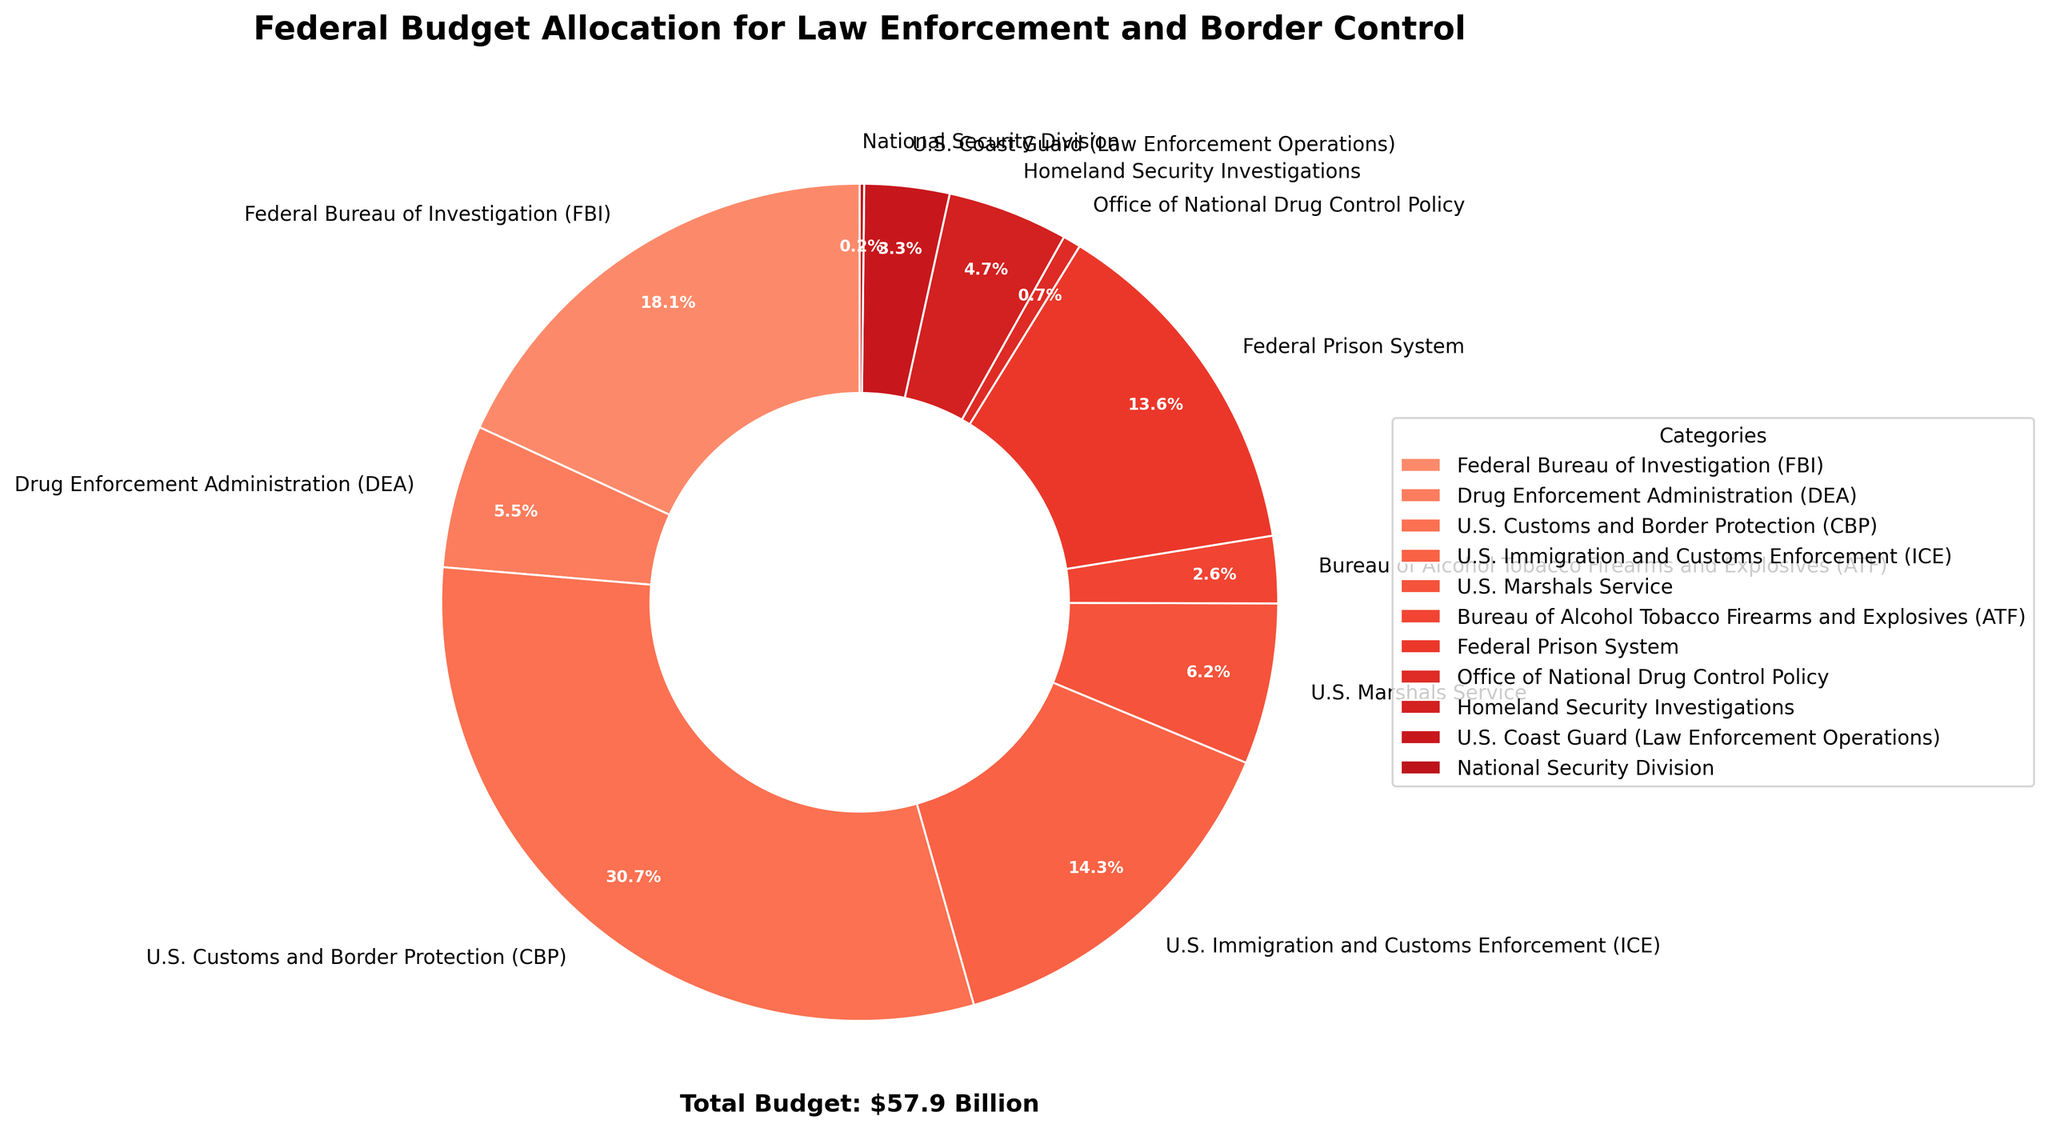What categories receive less than 5% of the total budget each? First, identify the categories with budget allocations below 5% from the pie chart. The total budget is 57.9 billion from the chart. For less than 5%, a category should receive less than 0.05 * 57.9 = 2.895 billion. The relevant categories are DEA, ATF, Office of National Drug Control Policy, Homeland Security Investigations, National Security Division, and U.S. Coast Guard (Law Enforcement Operations).
Answer: DEA, ATF, Office of National Drug Control Policy, Homeland Security Investigations, National Security Division, U.S. Coast Guard (Law Enforcement Operations) Which law enforcement category receives the highest budget allocation? Identify the category with the largest slice on the pie chart. Notably, U.S. Customs and Border Protection (CBP) occupies the largest portion.
Answer: U.S. Customs and Border Protection (CBP) Combined, which two law enforcement categories have the lowest total budget allocation? Identify the smallest slices from the chart. The two smallest slices are National Security Division ($0.1 billion) and Office of National Drug Control Policy ($0.4 billion). Summing these gives 0.1 + 0.4 = 0.5 billion.
Answer: National Security Division and Office of National Drug Control Policy How does the budget allocation for U.S. Immigration and Customs Enforcement (ICE) compare to the Federal Prison System? Observe the sizes of the corresponding slices. ICE has an allocation of 8.3 billion and the Federal Prison System has 7.9 billion. ICE’s allocation is higher than that of the Federal Prison System.
Answer: ICE's budget allocation is higher What is the combined budget allocation of the FBI, DEA, and ATF? Sum the allocations of FBI (10.5 billion), DEA (3.2 billion), and ATF (1.5 billion). The combined budget is 10.5 + 3.2 + 1.5 = 15.2 billion.
Answer: 15.2 billion Which category gets the smallest budget allocation, and how much is it? Identify the smallest slice on the chart, which is the National Security Division. Its budget allocation is 0.1 billion.
Answer: National Security Division, 0.1 billion By what percentage does the budget allocation for U.S. Customs and Border Protection (CBP) exceed that of the Drug Enforcement Administration (DEA)? First, find CBP's allocation (17.8 billion) and DEA’s allocation (3.2 billion). The difference is 17.8 - 3.2 = 14.6 billion. Calculate the percentage (14.6/3.2) * 100 ≈ 456.25%.
Answer: 456.25% How much more is allocated to the Federal Bureau of Investigation (FBI) compared to the U.S. Marshals Service? Identify their budget allocations: FBI (10.5 billion) and U.S. Marshals Service (3.6 billion). The difference is 10.5 - 3.6 = 6.9 billion.
Answer: 6.9 billion 